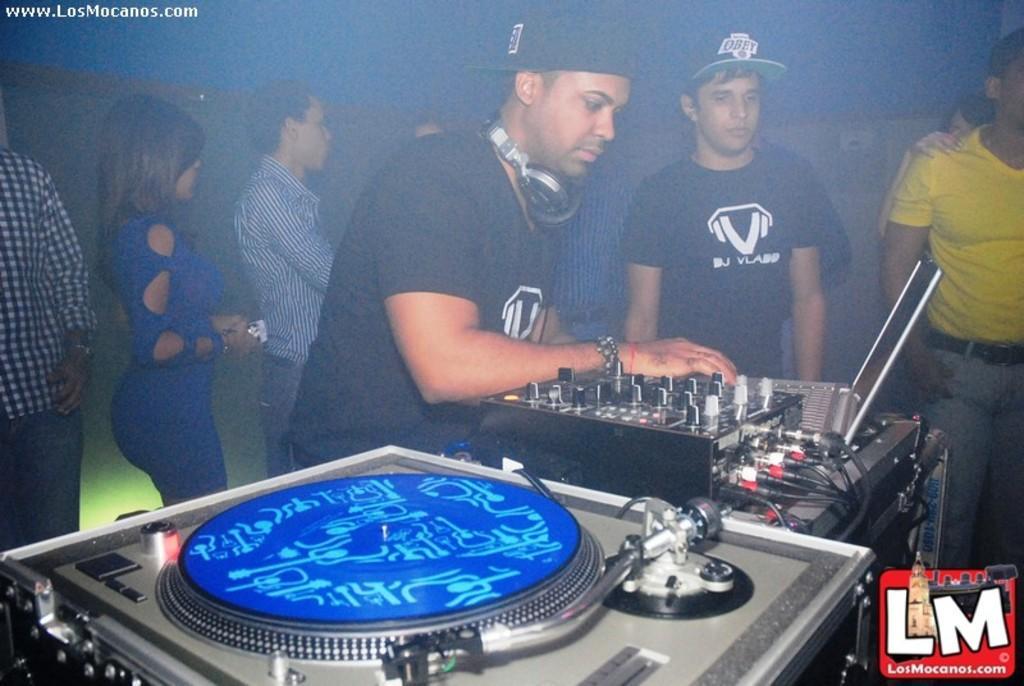In one or two sentences, can you explain what this image depicts? In the center of the image we can see a man standing and playing a dj. In the background there are people and we can see a light. 